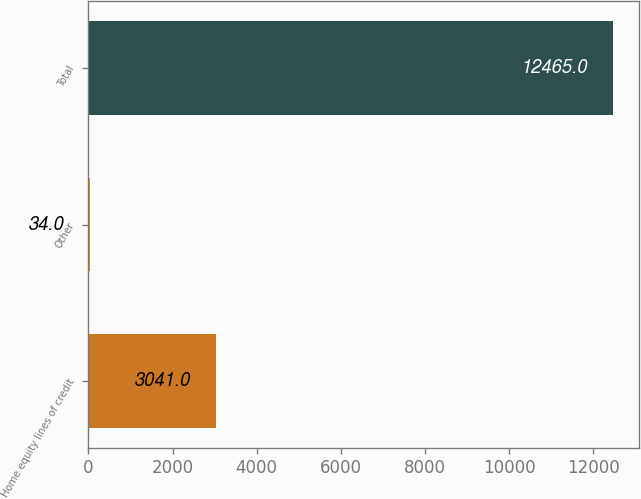Convert chart. <chart><loc_0><loc_0><loc_500><loc_500><bar_chart><fcel>Home equity lines of credit<fcel>Other<fcel>Total<nl><fcel>3041<fcel>34<fcel>12465<nl></chart> 